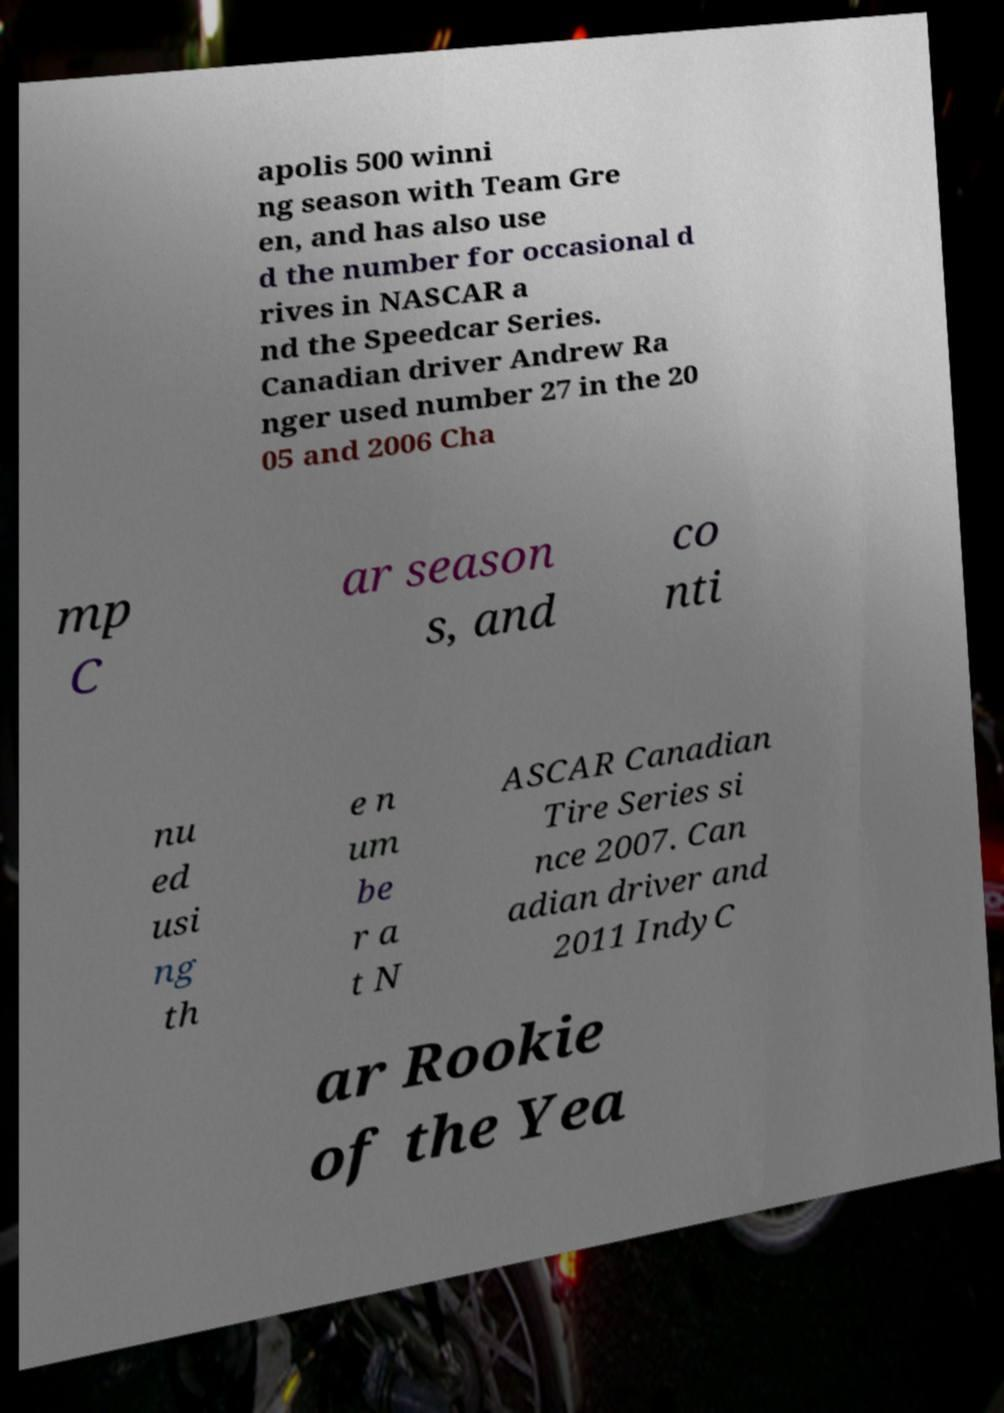What messages or text are displayed in this image? I need them in a readable, typed format. apolis 500 winni ng season with Team Gre en, and has also use d the number for occasional d rives in NASCAR a nd the Speedcar Series. Canadian driver Andrew Ra nger used number 27 in the 20 05 and 2006 Cha mp C ar season s, and co nti nu ed usi ng th e n um be r a t N ASCAR Canadian Tire Series si nce 2007. Can adian driver and 2011 IndyC ar Rookie of the Yea 